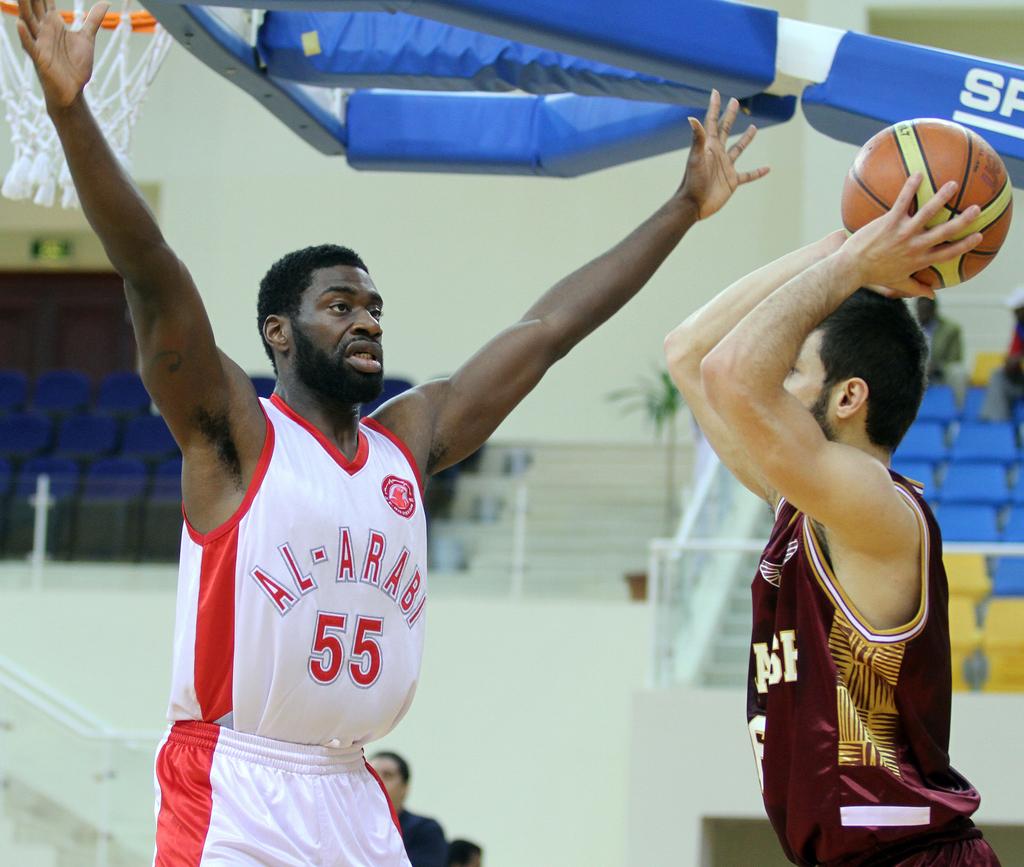What is 2 letters shown on the goal post?
Your answer should be very brief. Sp. 